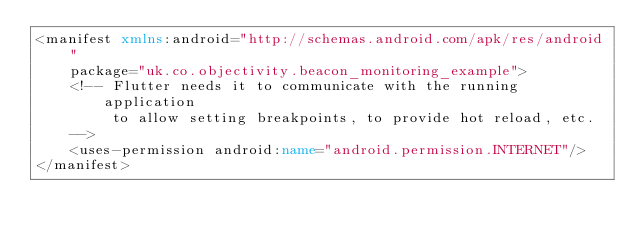Convert code to text. <code><loc_0><loc_0><loc_500><loc_500><_XML_><manifest xmlns:android="http://schemas.android.com/apk/res/android"
    package="uk.co.objectivity.beacon_monitoring_example">
    <!-- Flutter needs it to communicate with the running application
         to allow setting breakpoints, to provide hot reload, etc.
    -->
    <uses-permission android:name="android.permission.INTERNET"/>
</manifest>
</code> 